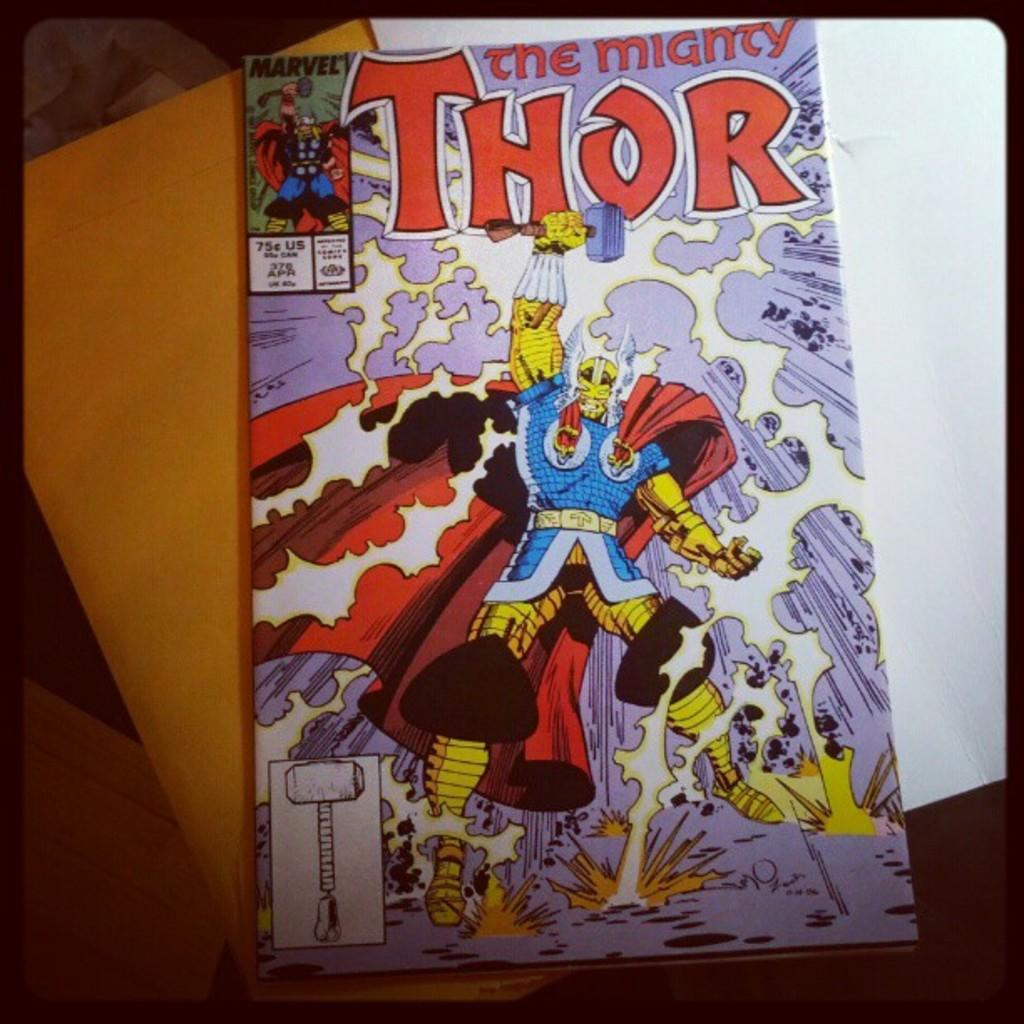<image>
Give a short and clear explanation of the subsequent image. A comic book of Thor the mighty is on the table on top of some papers. 